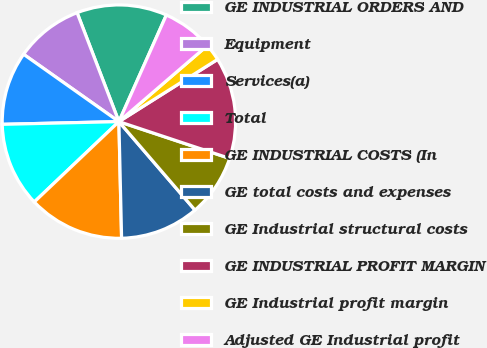Convert chart to OTSL. <chart><loc_0><loc_0><loc_500><loc_500><pie_chart><fcel>GE INDUSTRIAL ORDERS AND<fcel>Equipment<fcel>Services(a)<fcel>Total<fcel>GE INDUSTRIAL COSTS (In<fcel>GE total costs and expenses<fcel>GE Industrial structural costs<fcel>GE INDUSTRIAL PROFIT MARGIN<fcel>GE Industrial profit margin<fcel>Adjusted GE Industrial profit<nl><fcel>12.5%<fcel>9.38%<fcel>10.16%<fcel>11.72%<fcel>13.28%<fcel>10.94%<fcel>8.59%<fcel>14.06%<fcel>2.35%<fcel>7.03%<nl></chart> 